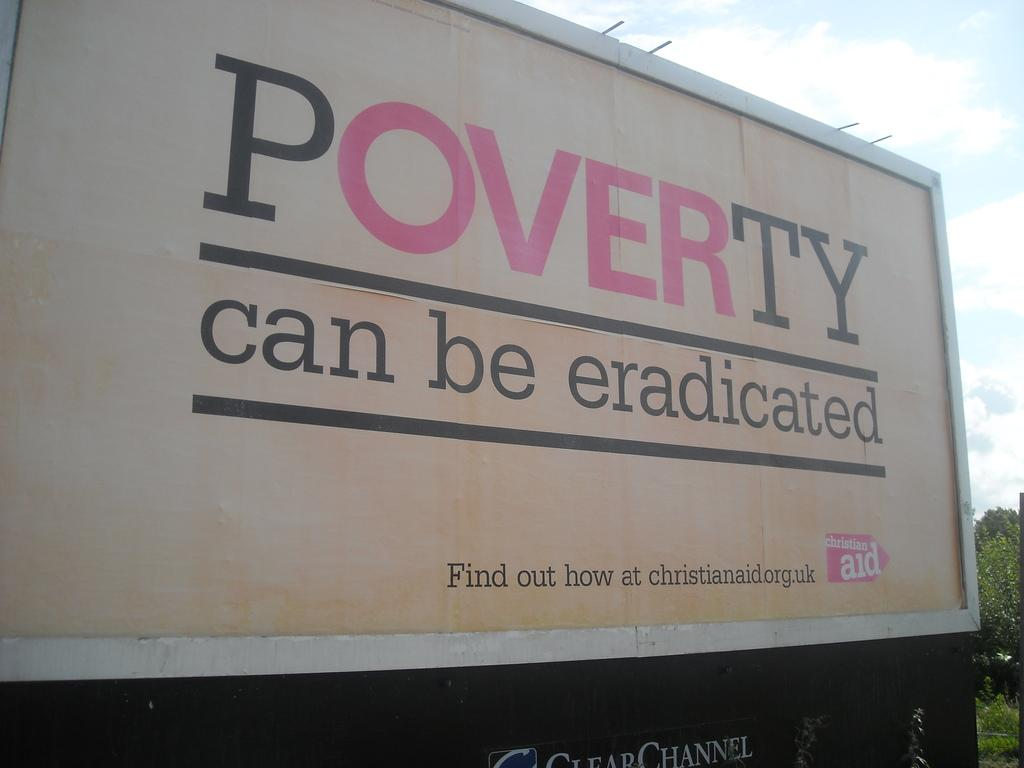<image>
Summarize the visual content of the image. A billboard that reads, poverty can be eradicated, find out how at christianaid.org.uk, christian aid. 